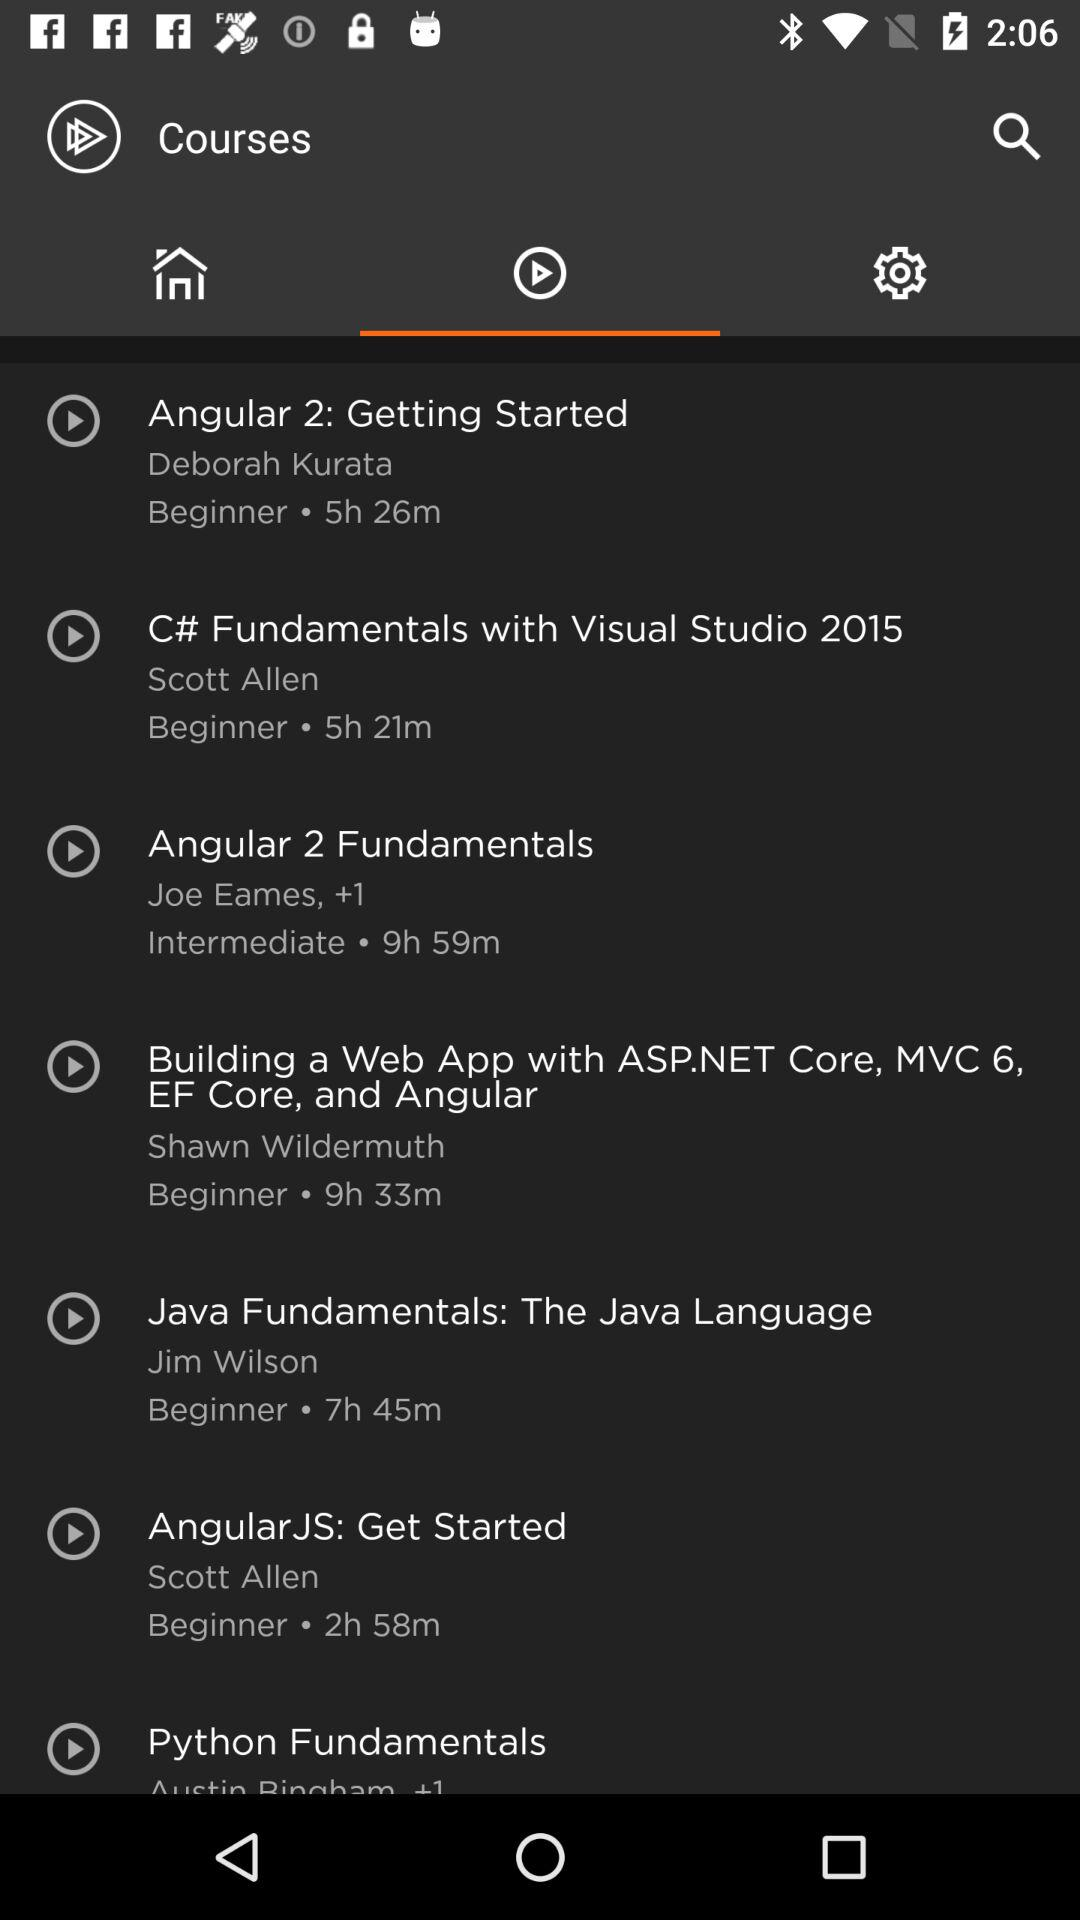What course has a minimum duration? The course that has a minimum duration is "C# Fundamentals with Visual Studio 2015". 